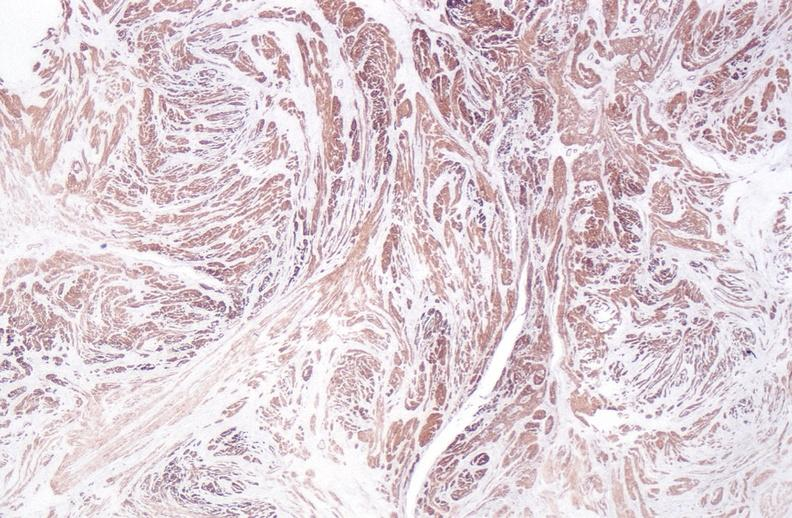does this image show leiomyoma?
Answer the question using a single word or phrase. Yes 